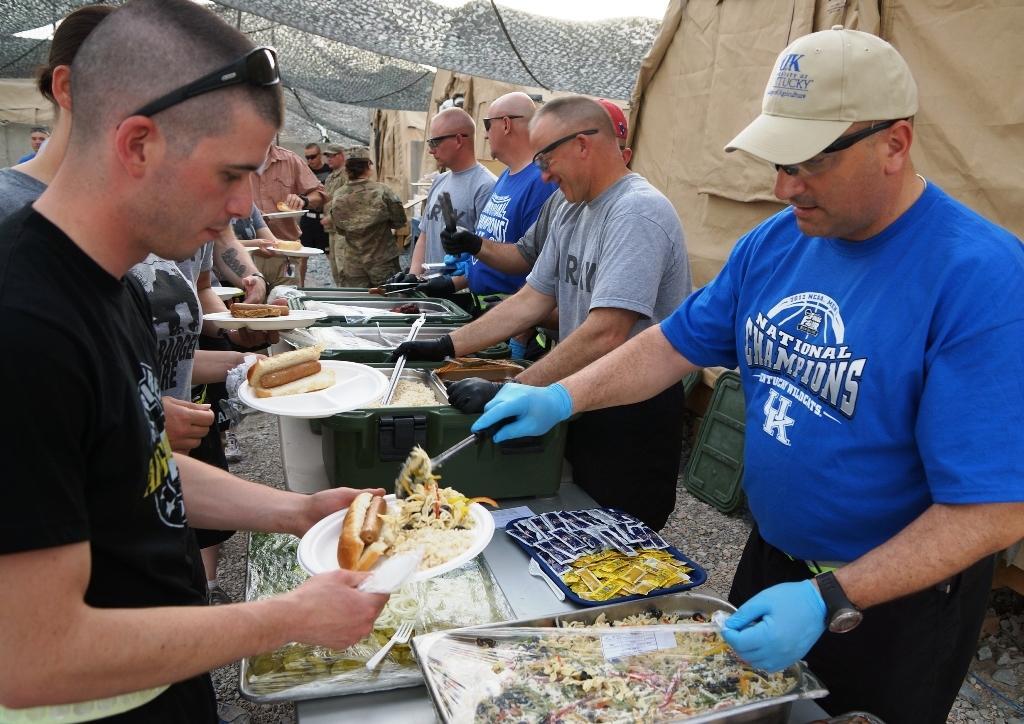How would you summarize this image in a sentence or two? In this image I can see number of people are standing and I can see most of them are wearing goggles. On the left side I can see few people are holding plates and in these places I can see different types of food. On the right side I can see few people are wearing gloves and I can see few of them are holding spoons. In the centre I can see few tables and on it I can see containers, plates and food. In the background I can see few tent houses and on the right side I can see one person is wearing a cap. 